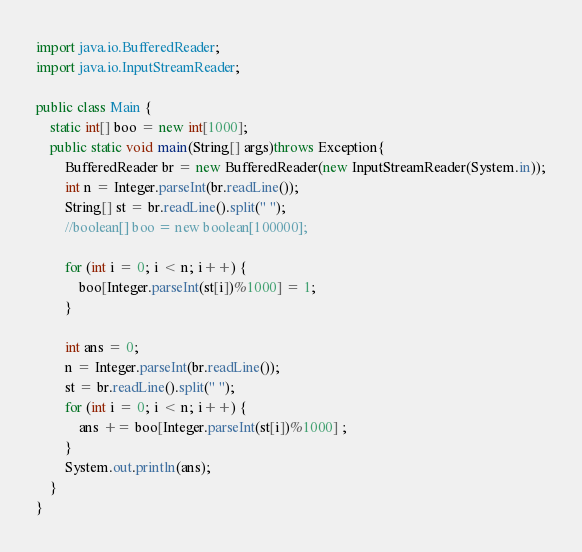<code> <loc_0><loc_0><loc_500><loc_500><_Java_>import java.io.BufferedReader;
import java.io.InputStreamReader;

public class Main {
	static int[] boo = new int[1000];
	public static void main(String[] args)throws Exception{
		BufferedReader br = new BufferedReader(new InputStreamReader(System.in));
		int n = Integer.parseInt(br.readLine());
		String[] st = br.readLine().split(" ");
		//boolean[] boo = new boolean[100000];
		
		for (int i = 0; i < n; i++) {
			boo[Integer.parseInt(st[i])%1000] = 1;
		}
		
		int ans = 0;
		n = Integer.parseInt(br.readLine());
		st = br.readLine().split(" ");
		for (int i = 0; i < n; i++) {
			ans += boo[Integer.parseInt(st[i])%1000] ;
		}
		System.out.println(ans);
	}
}</code> 